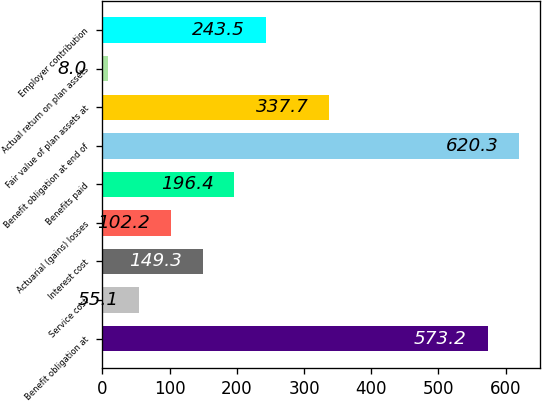Convert chart. <chart><loc_0><loc_0><loc_500><loc_500><bar_chart><fcel>Benefit obligation at<fcel>Service cost<fcel>Interest cost<fcel>Actuarial (gains) losses<fcel>Benefits paid<fcel>Benefit obligation at end of<fcel>Fair value of plan assets at<fcel>Actual return on plan assets<fcel>Employer contribution<nl><fcel>573.2<fcel>55.1<fcel>149.3<fcel>102.2<fcel>196.4<fcel>620.3<fcel>337.7<fcel>8<fcel>243.5<nl></chart> 